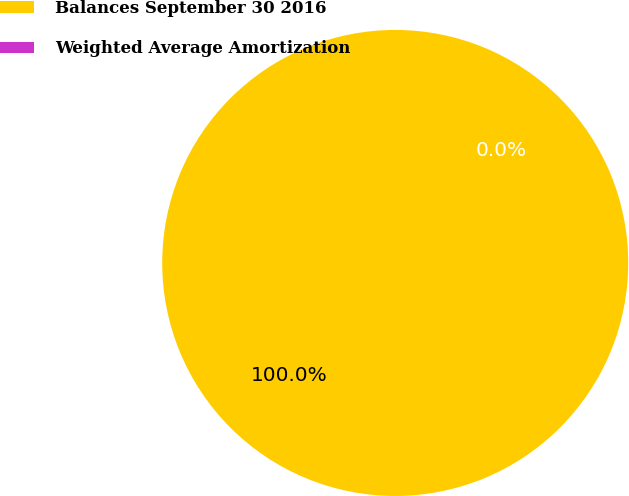Convert chart. <chart><loc_0><loc_0><loc_500><loc_500><pie_chart><fcel>Balances September 30 2016<fcel>Weighted Average Amortization<nl><fcel>100.0%<fcel>0.0%<nl></chart> 